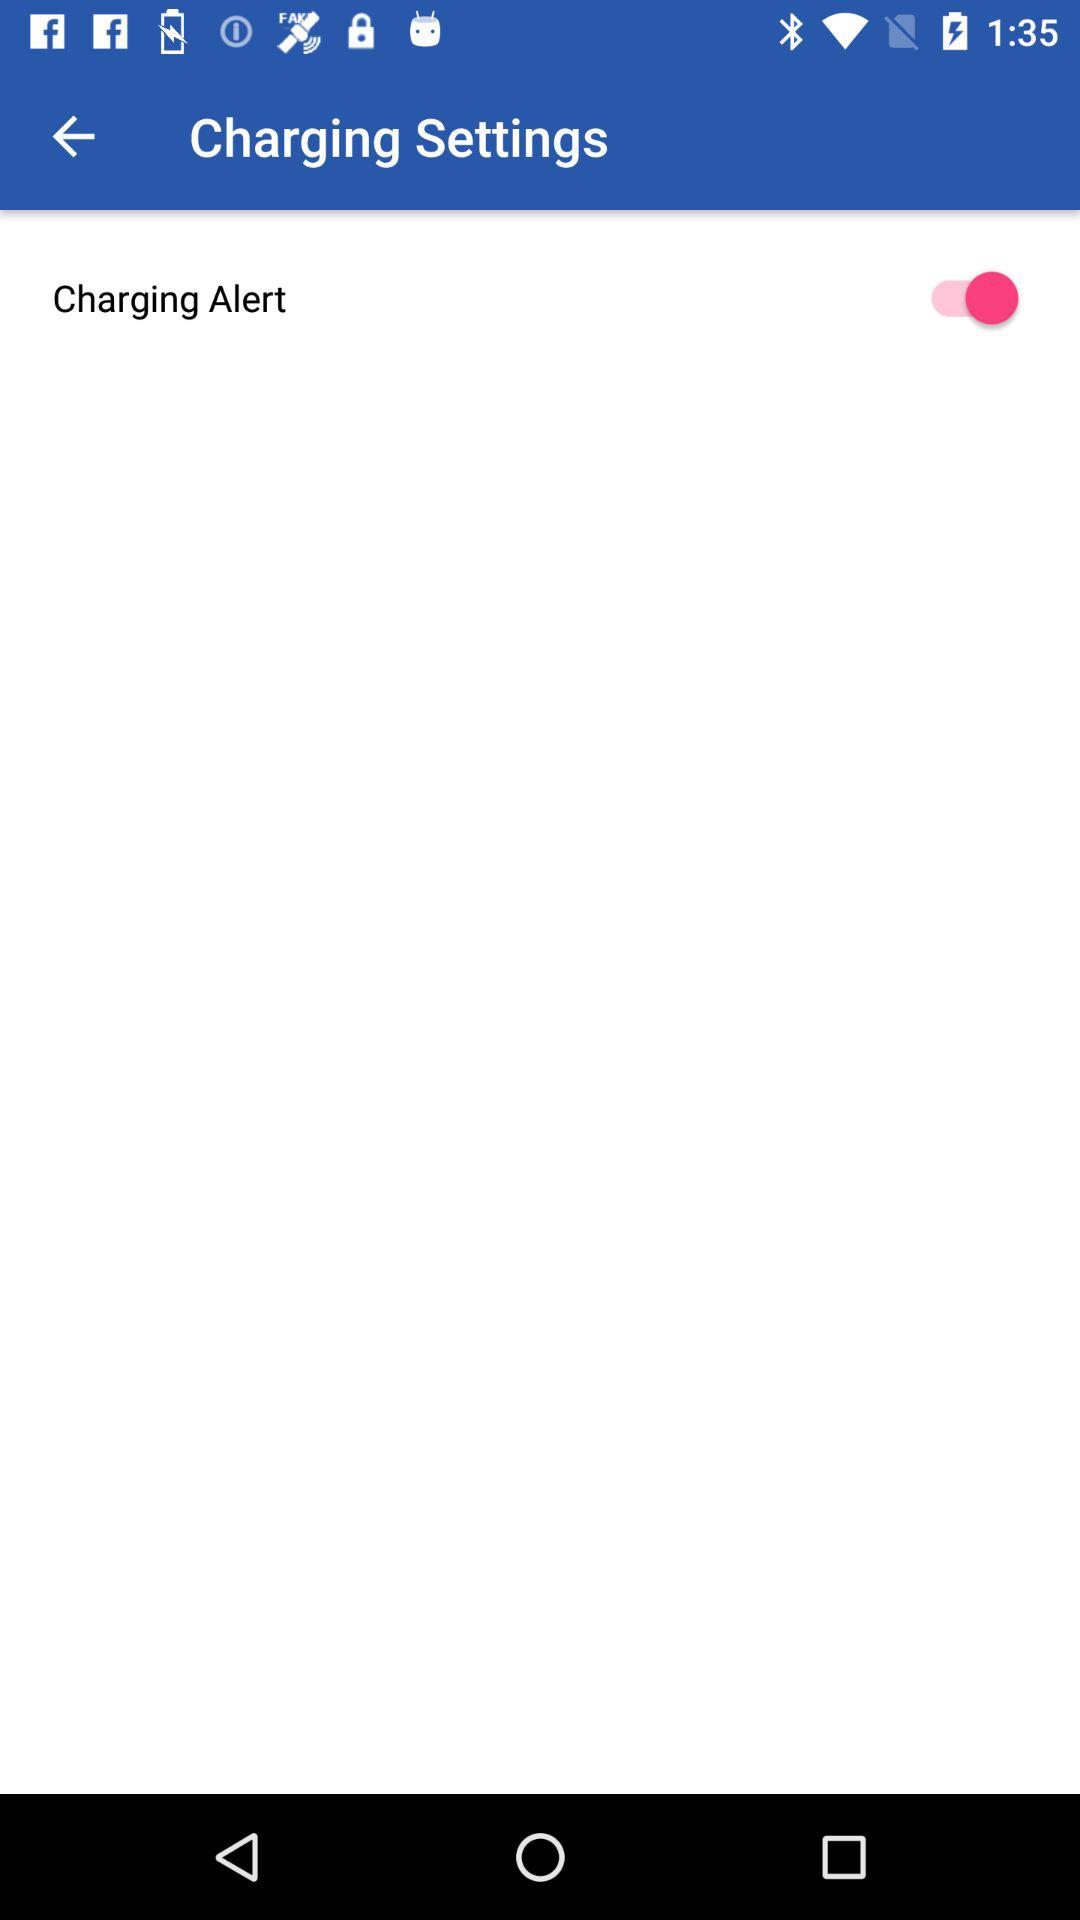What's the status of the "Charging Alert"? The status is on. 